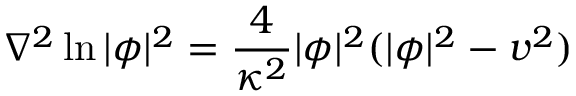Convert formula to latex. <formula><loc_0><loc_0><loc_500><loc_500>\nabla ^ { 2 } \ln | \phi | ^ { 2 } = \frac { 4 } { \kappa ^ { 2 } } | \phi | ^ { 2 } ( | \phi | ^ { 2 } - v ^ { 2 } )</formula> 